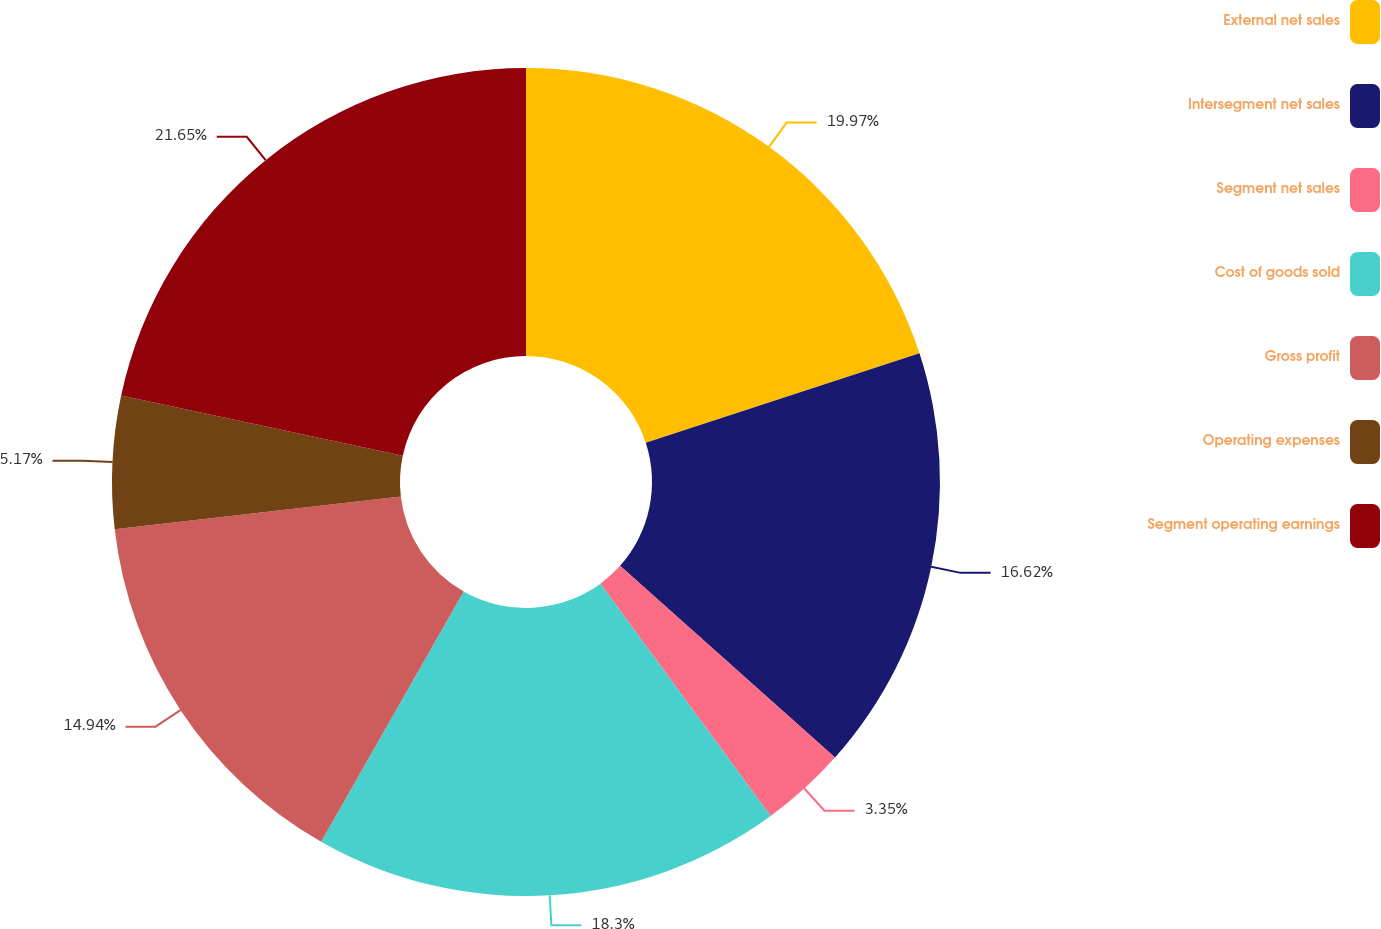Convert chart. <chart><loc_0><loc_0><loc_500><loc_500><pie_chart><fcel>External net sales<fcel>Intersegment net sales<fcel>Segment net sales<fcel>Cost of goods sold<fcel>Gross profit<fcel>Operating expenses<fcel>Segment operating earnings<nl><fcel>19.97%<fcel>16.62%<fcel>3.35%<fcel>18.3%<fcel>14.94%<fcel>5.17%<fcel>21.65%<nl></chart> 